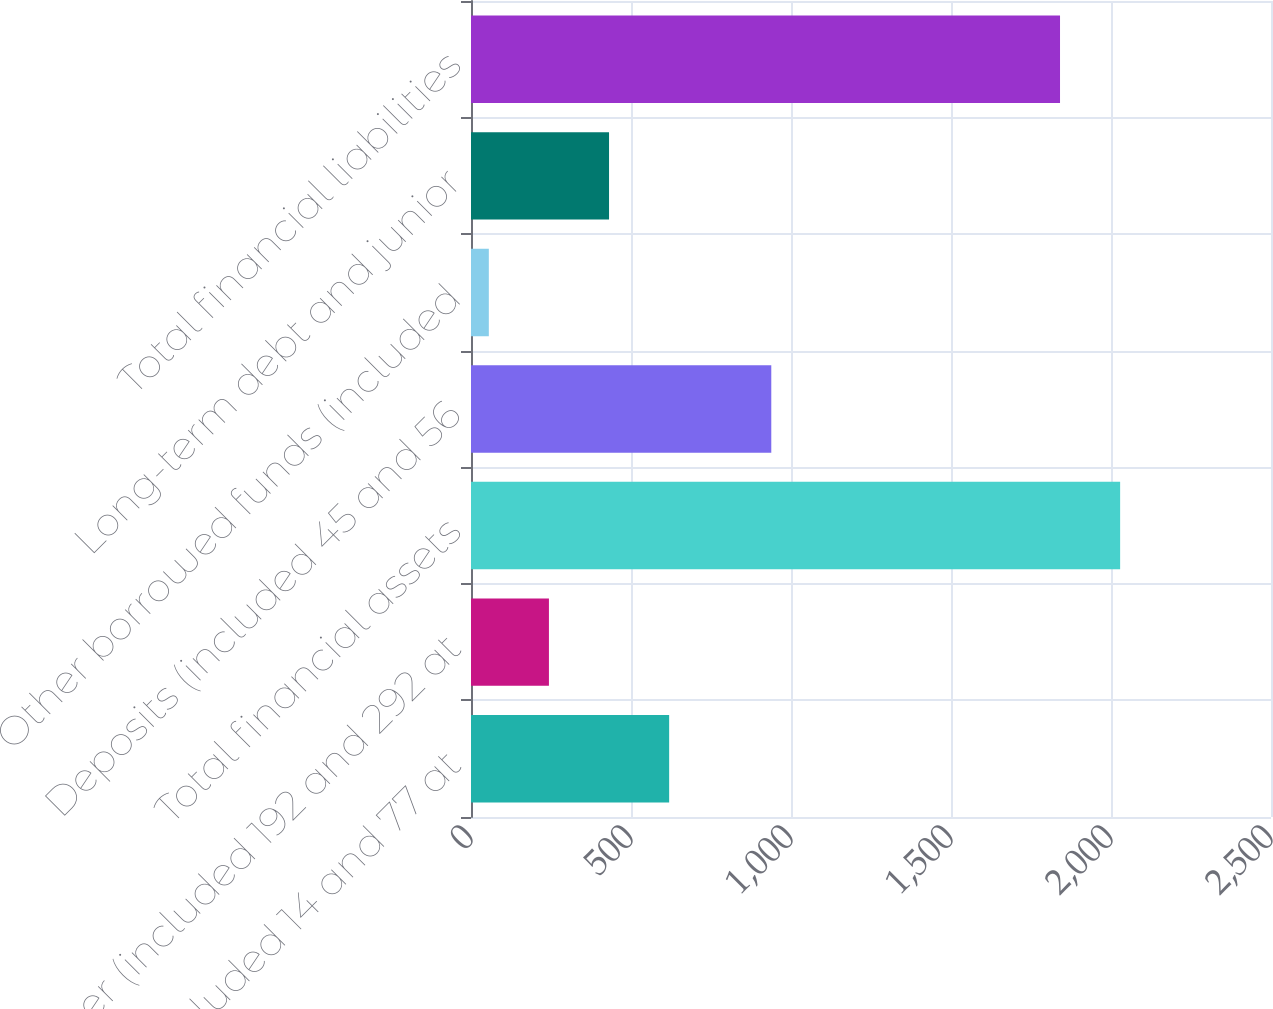Convert chart. <chart><loc_0><loc_0><loc_500><loc_500><bar_chart><fcel>Loans (included 14 and 77 at<fcel>Other (included 192 and 292 at<fcel>Total financial assets<fcel>Deposits (included 45 and 56<fcel>Other borrowed funds (included<fcel>Long-term debt and junior<fcel>Total financial liabilities<nl><fcel>619.22<fcel>243.54<fcel>2028.54<fcel>938.4<fcel>55.7<fcel>431.38<fcel>1840.7<nl></chart> 